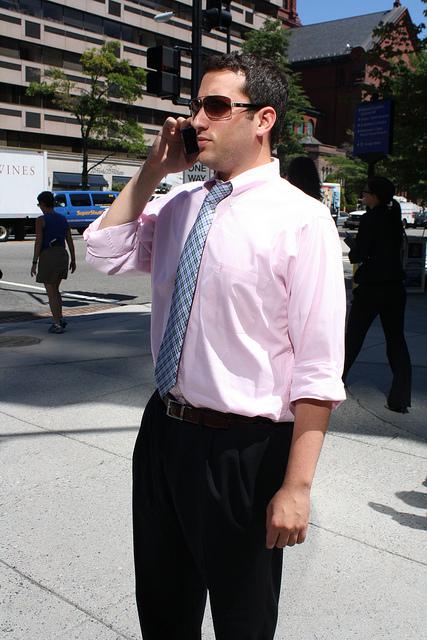Is the man wearing an official outfit?
Give a very brief answer. Yes. Is this man on a business call?
Quick response, please. Yes. Who is the man calling?
Concise answer only. Boss. What color is the van in the background?
Short answer required. Blue. What is the man talking on?
Give a very brief answer. Phone. 